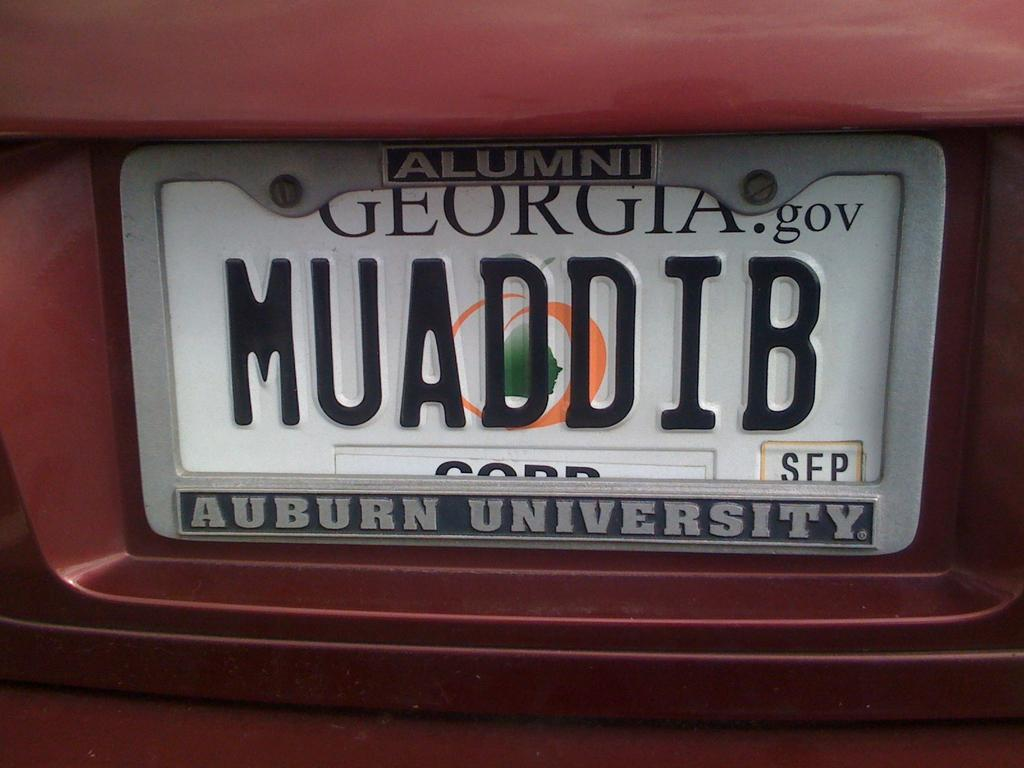<image>
Create a compact narrative representing the image presented. An Auburn Unoversity frame surrounds the Georgia license plate 